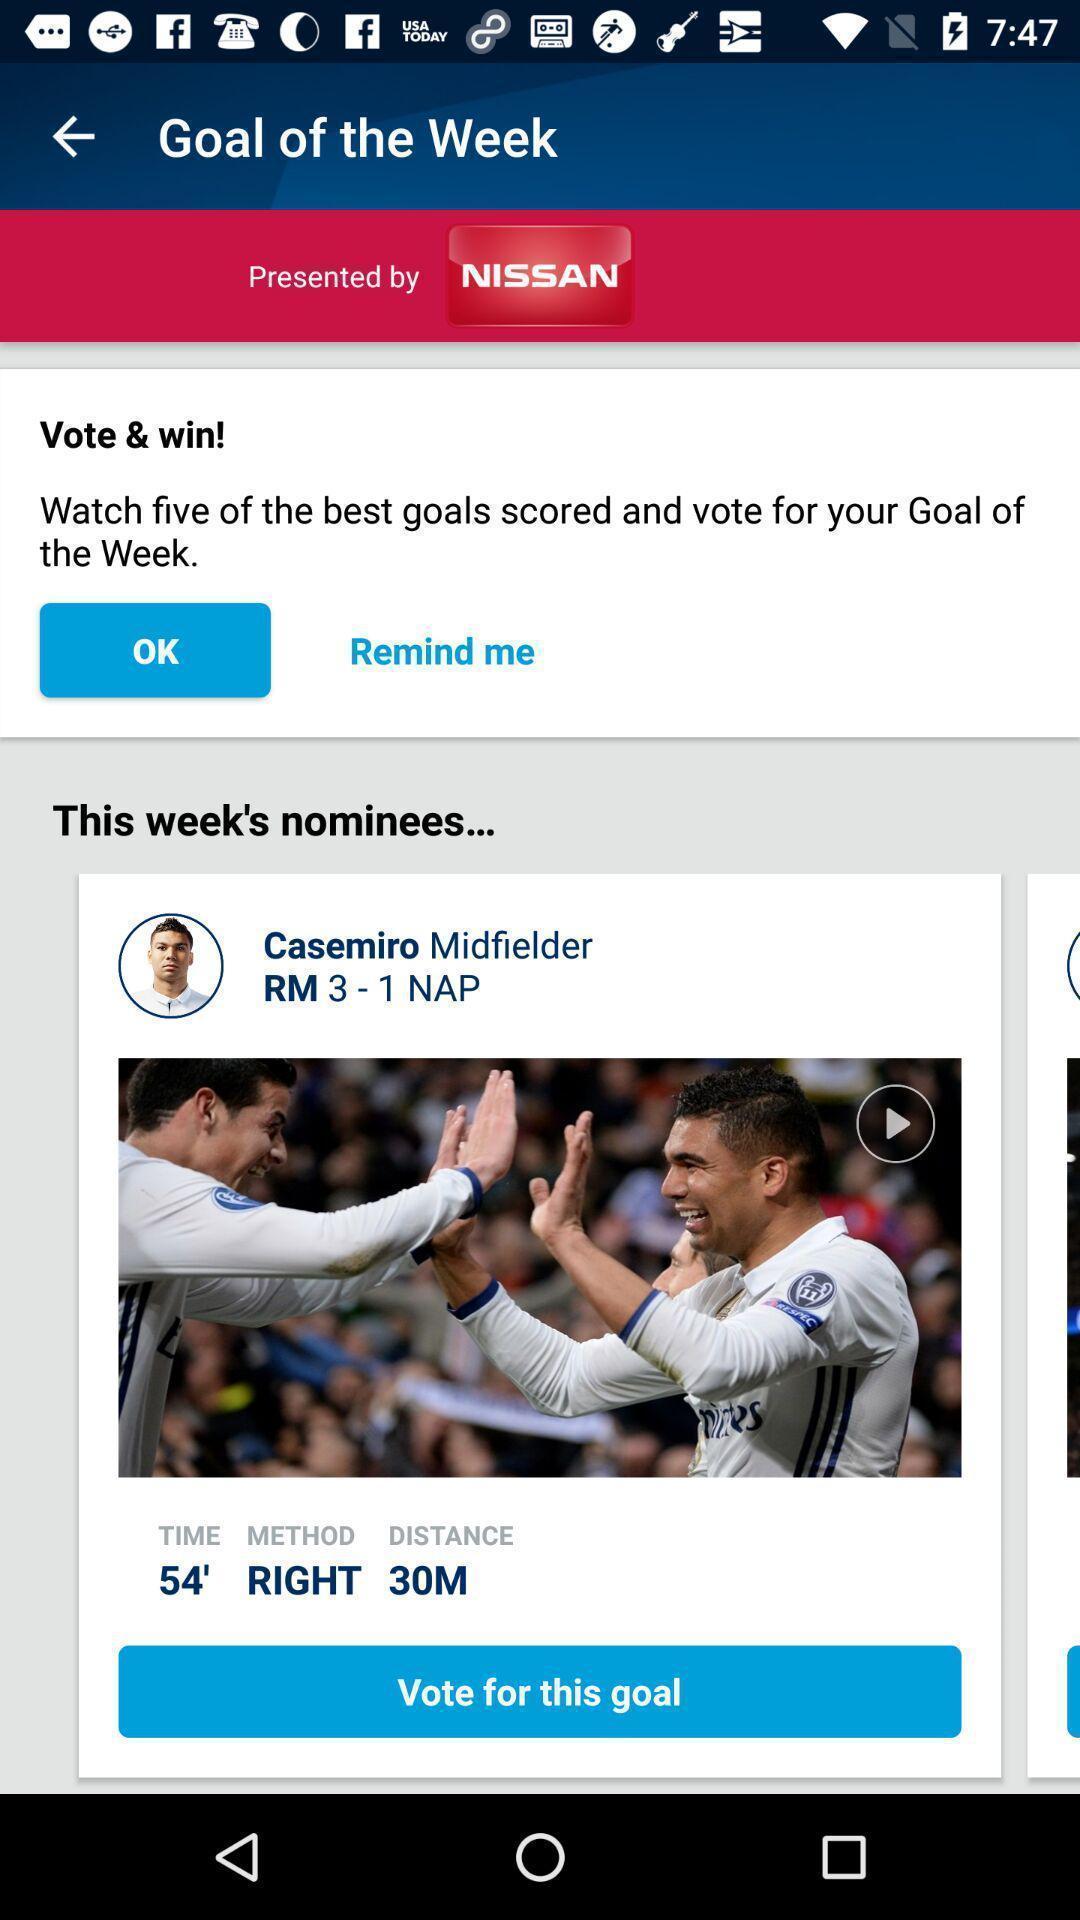Tell me what you see in this picture. Page of a sports app showing the voting option. 